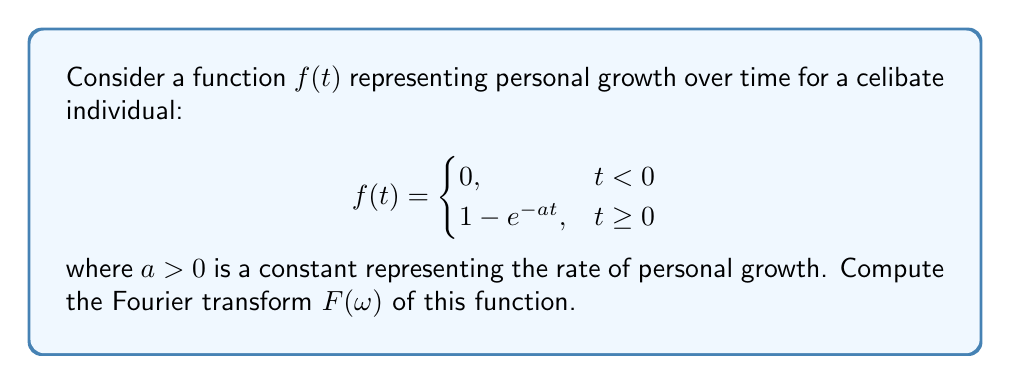Can you solve this math problem? To compute the Fourier transform of $f(t)$, we use the definition:

$$F(\omega) = \int_{-\infty}^{\infty} f(t) e^{-i\omega t} dt$$

Given the piecewise nature of $f(t)$, we can split the integral:

$$F(\omega) = \int_{0}^{\infty} (1 - e^{-at}) e^{-i\omega t} dt$$

Let's solve this integral in two parts:

1. $\int_{0}^{\infty} e^{-i\omega t} dt$
2. $-\int_{0}^{\infty} e^{-at} e^{-i\omega t} dt$

For the first part:
$$\int_{0}^{\infty} e^{-i\omega t} dt = \left[-\frac{1}{i\omega} e^{-i\omega t}\right]_{0}^{\infty} = \frac{1}{i\omega}$$

For the second part:
$$-\int_{0}^{\infty} e^{-at} e^{-i\omega t} dt = -\int_{0}^{\infty} e^{-(a+i\omega)t} dt = -\left[-\frac{1}{a+i\omega} e^{-(a+i\omega)t}\right]_{0}^{\infty} = -\frac{1}{a+i\omega}$$

Combining these results:

$$F(\omega) = \frac{1}{i\omega} - \frac{1}{a+i\omega} = \frac{a+i\omega}{i\omega(a+i\omega)} = \frac{a+i\omega}{-\omega^2+ia\omega}$$

Simplifying the complex fraction:

$$F(\omega) = \frac{a+i\omega}{-\omega^2+ia\omega} \cdot \frac{-\omega^2-ia\omega}{-\omega^2-ia\omega} = \frac{a^2+\omega^2}{a^2+\omega^2} - i\frac{a\omega}{a^2+\omega^2}$$

This represents the Fourier transform of the personal growth function.
Answer: $$F(\omega) = \frac{a^2+\omega^2}{a^2+\omega^2} - i\frac{a\omega}{a^2+\omega^2}$$ 